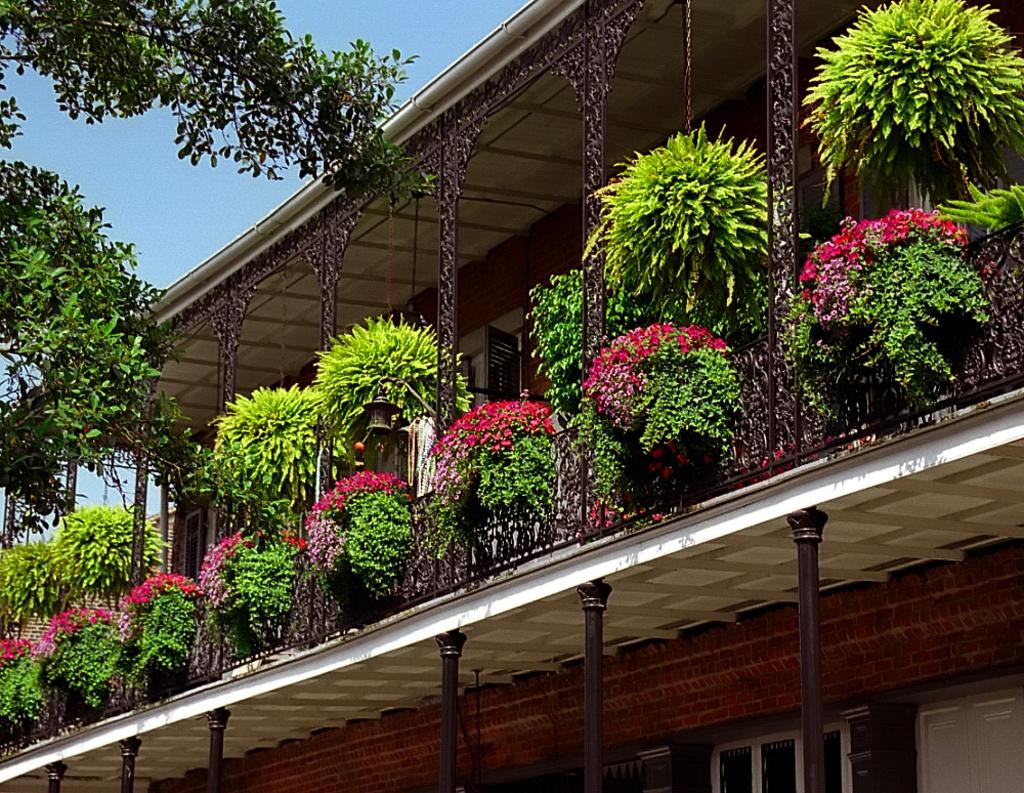What type of structure is present in the image? There is a building in the image. What are the poles used for in the image? The purpose of the poles is not specified, but they are visible in the image. What type of vegetation can be seen in the image? There are potted plants, flowers, and trees in the image. What part of the building can be seen in the image? There are windows visible in the image. What is visible in the background of the image? The sky is visible in the image. Where is the monkey sitting on the roof in the image? There is no monkey or roof present in the image. What type of mailbox can be seen near the trees in the image? There is no mailbox present in the image. 